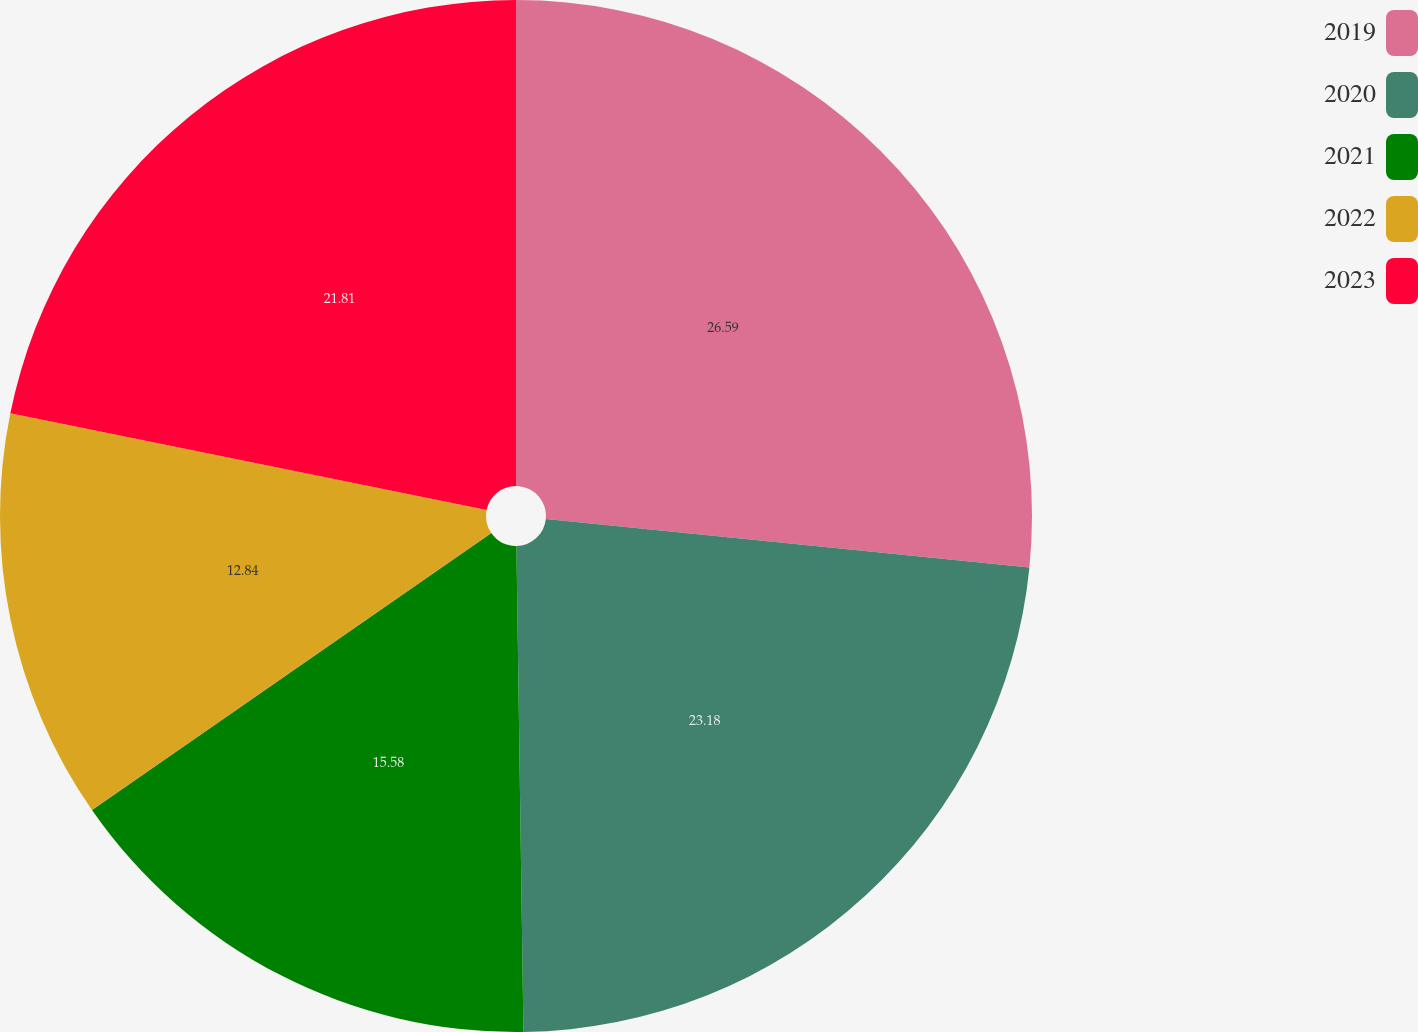Convert chart to OTSL. <chart><loc_0><loc_0><loc_500><loc_500><pie_chart><fcel>2019<fcel>2020<fcel>2021<fcel>2022<fcel>2023<nl><fcel>26.59%<fcel>23.18%<fcel>15.58%<fcel>12.84%<fcel>21.81%<nl></chart> 